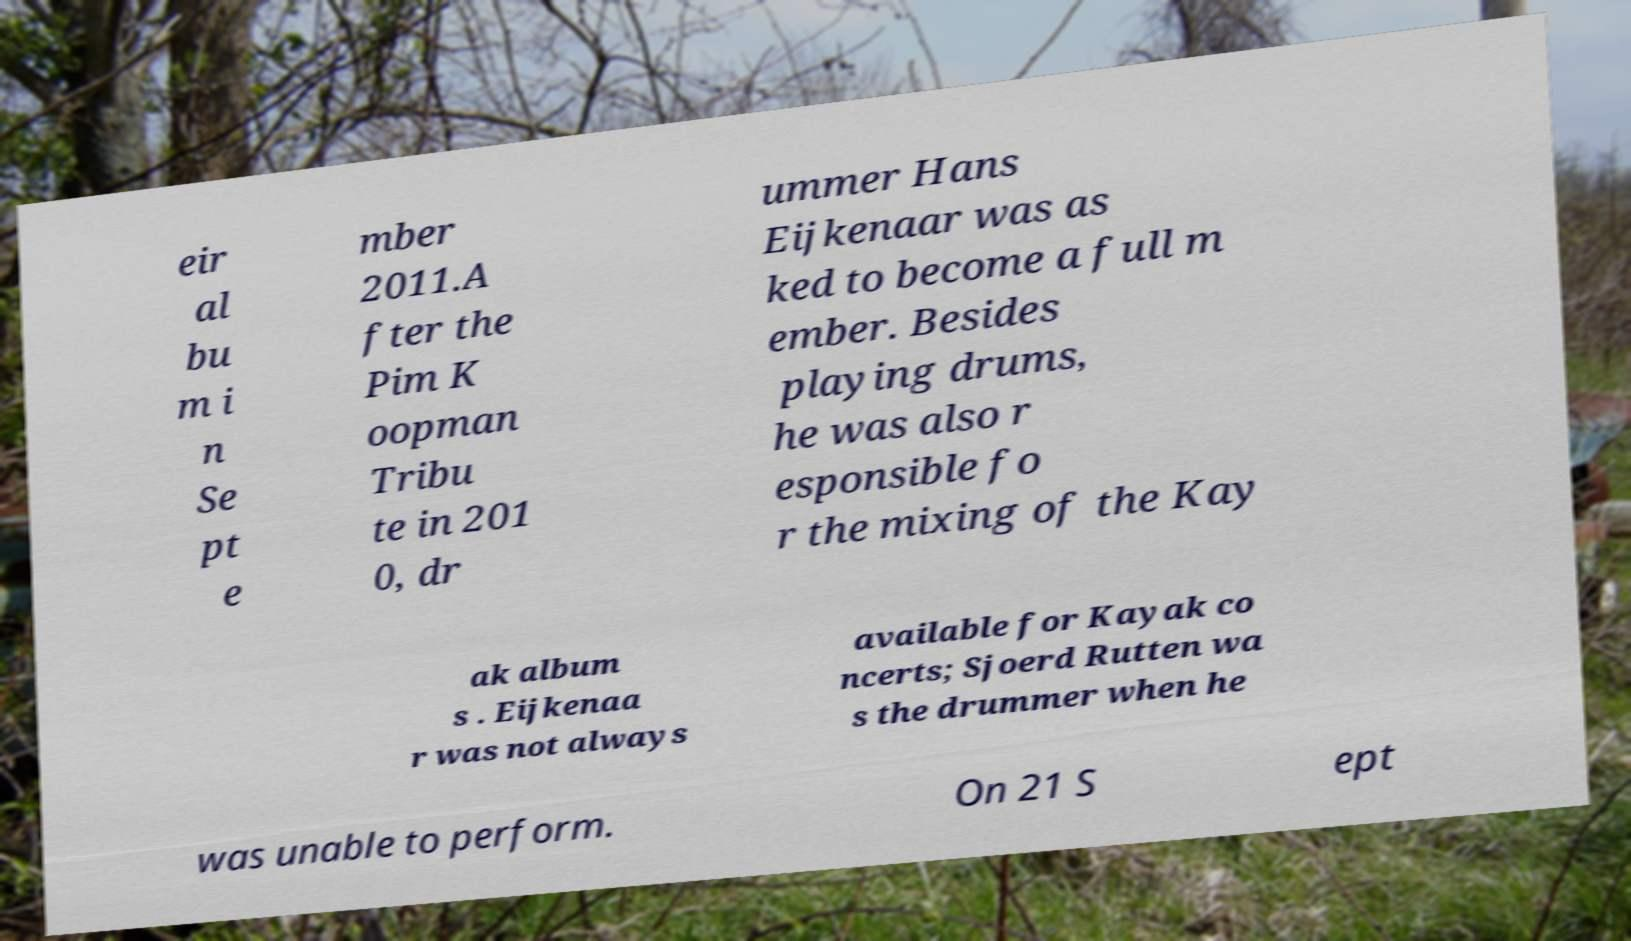What messages or text are displayed in this image? I need them in a readable, typed format. eir al bu m i n Se pt e mber 2011.A fter the Pim K oopman Tribu te in 201 0, dr ummer Hans Eijkenaar was as ked to become a full m ember. Besides playing drums, he was also r esponsible fo r the mixing of the Kay ak album s . Eijkenaa r was not always available for Kayak co ncerts; Sjoerd Rutten wa s the drummer when he was unable to perform. On 21 S ept 